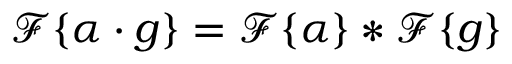Convert formula to latex. <formula><loc_0><loc_0><loc_500><loc_500>{ \mathcal { F } } \{ \alpha \cdot g \} = { \mathcal { F } } \{ \alpha \} * { \mathcal { F } } \{ g \}</formula> 